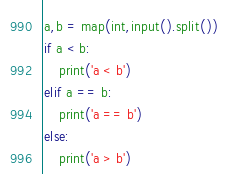Convert code to text. <code><loc_0><loc_0><loc_500><loc_500><_Python_>a,b = map(int,input().split())
if a < b:
    print('a < b')
elif a == b:
    print('a == b')
else:
    print('a > b')
</code> 